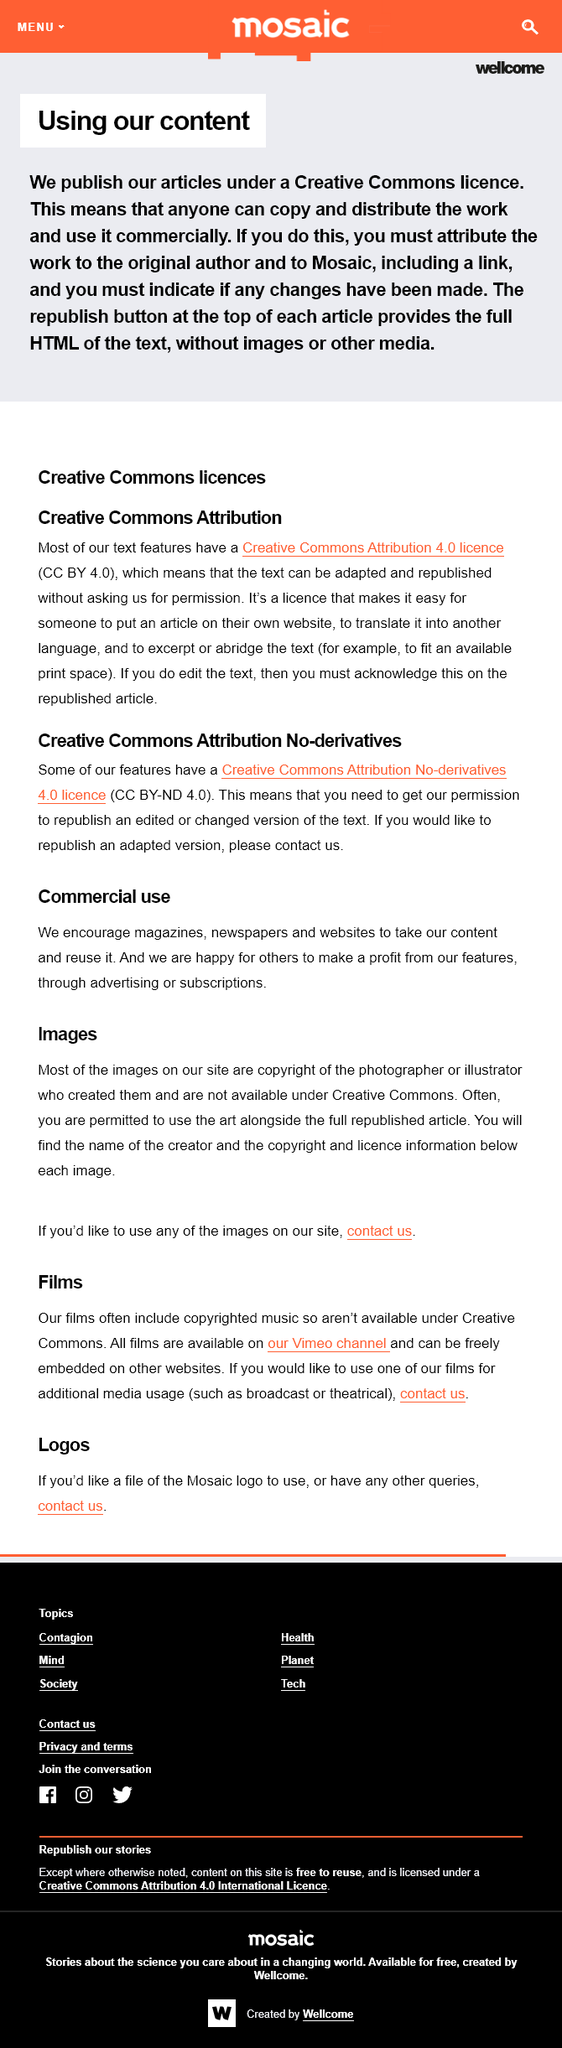Highlight a few significant elements in this photo. When using the republish button, the article is provided to the user in the format of HTML. The articles are licensed under a Creative Commons license. Our text features are licensed under the Creative Commons Attribution 4.0 license. 